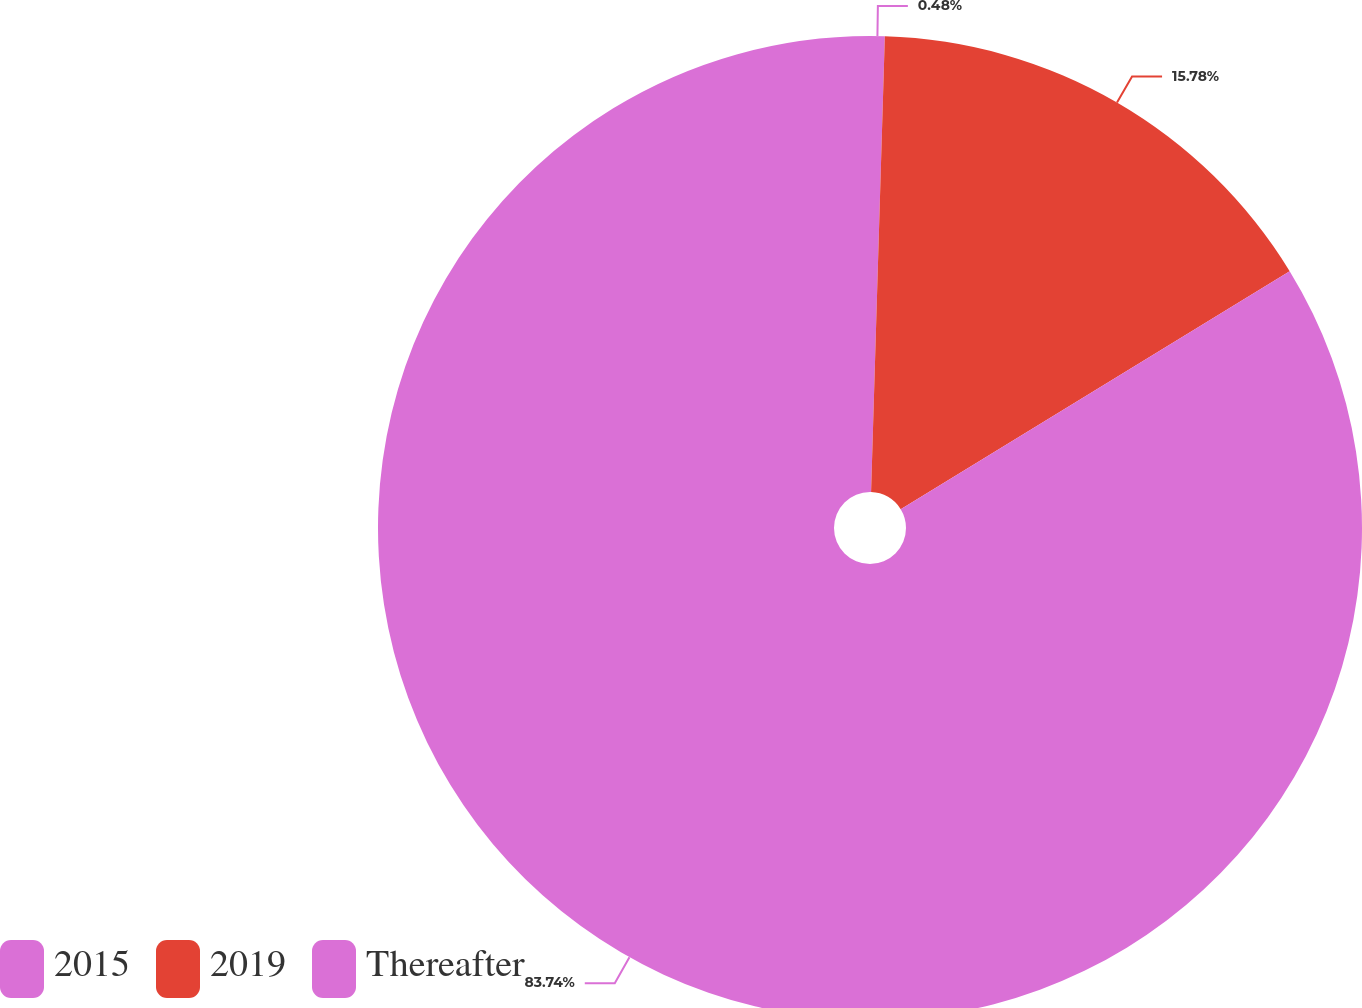<chart> <loc_0><loc_0><loc_500><loc_500><pie_chart><fcel>2015<fcel>2019<fcel>Thereafter<nl><fcel>0.48%<fcel>15.78%<fcel>83.73%<nl></chart> 